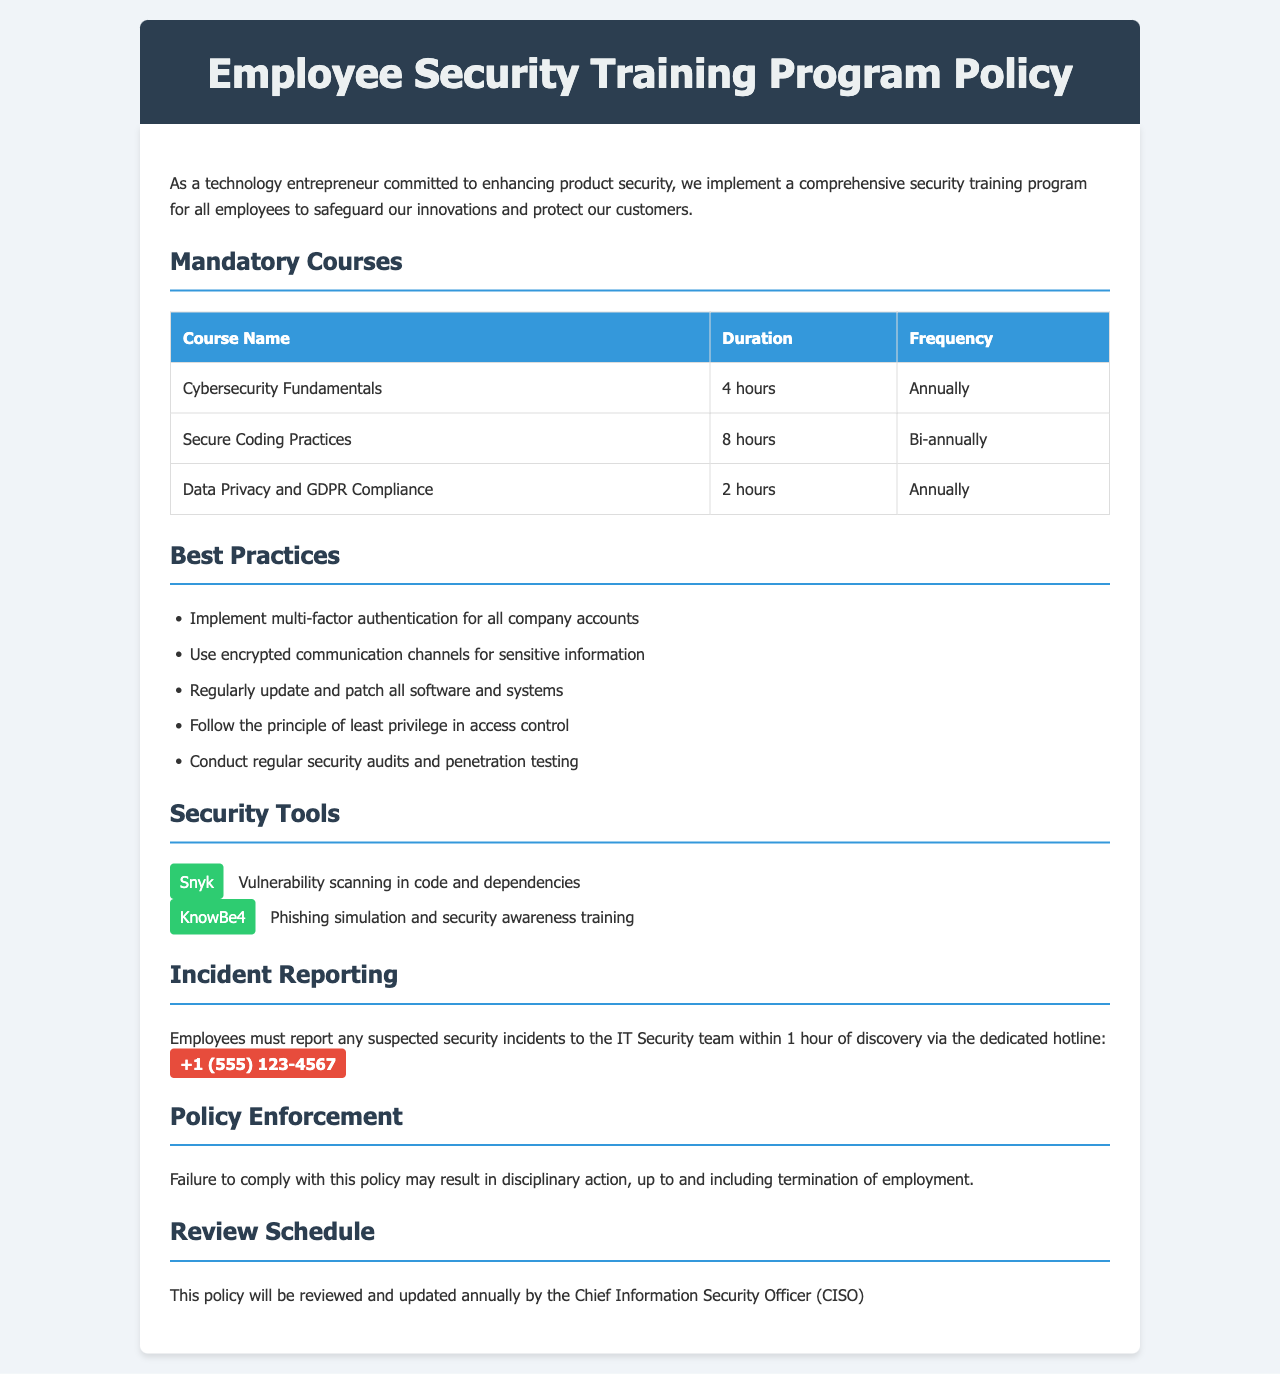What is the duration of the Cybersecurity Fundamentals course? The duration of the Cybersecurity Fundamentals course is specified in the document under the mandatory courses section.
Answer: 4 hours How often do employees need to take the Secure Coding Practices course? The frequency for the Secure Coding Practices course is listed in the mandatory courses table, indicating how often it should be taken.
Answer: Bi-annually What is one of the recommended best practices for maintaining product security? The document outlines several best practices for maintaining product security under the best practices section.
Answer: Implement multi-factor authentication for all company accounts What should employees do within one hour of discovering a security incident? The incident reporting section details the expected action from employees regarding suspected security incidents.
Answer: Report to the IT Security team Who is responsible for reviewing this policy annually? The document specifies who will be responsible for reviewing and updating the policy each year.
Answer: Chief Information Security Officer (CISO) How many mandatory courses are listed in the policy? The count of mandatory courses is determined by listing each course under the mandatory courses section in the document.
Answer: 3 What is the contact number for reporting security incidents? The document provides a specific hotline number that employees should use to report security incidents.
Answer: +1 (555) 123-4567 What consequence is stated for non-compliance with the policy? The policy enforcement section mentions the potential disciplinary actions for not adhering to the policy.
Answer: Termination of employment 